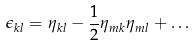Convert formula to latex. <formula><loc_0><loc_0><loc_500><loc_500>\epsilon _ { k l } = \eta _ { k l } - \frac { 1 } { 2 } \eta _ { m k } \eta _ { m l } + \dots</formula> 